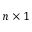Convert formula to latex. <formula><loc_0><loc_0><loc_500><loc_500>n \times 1</formula> 